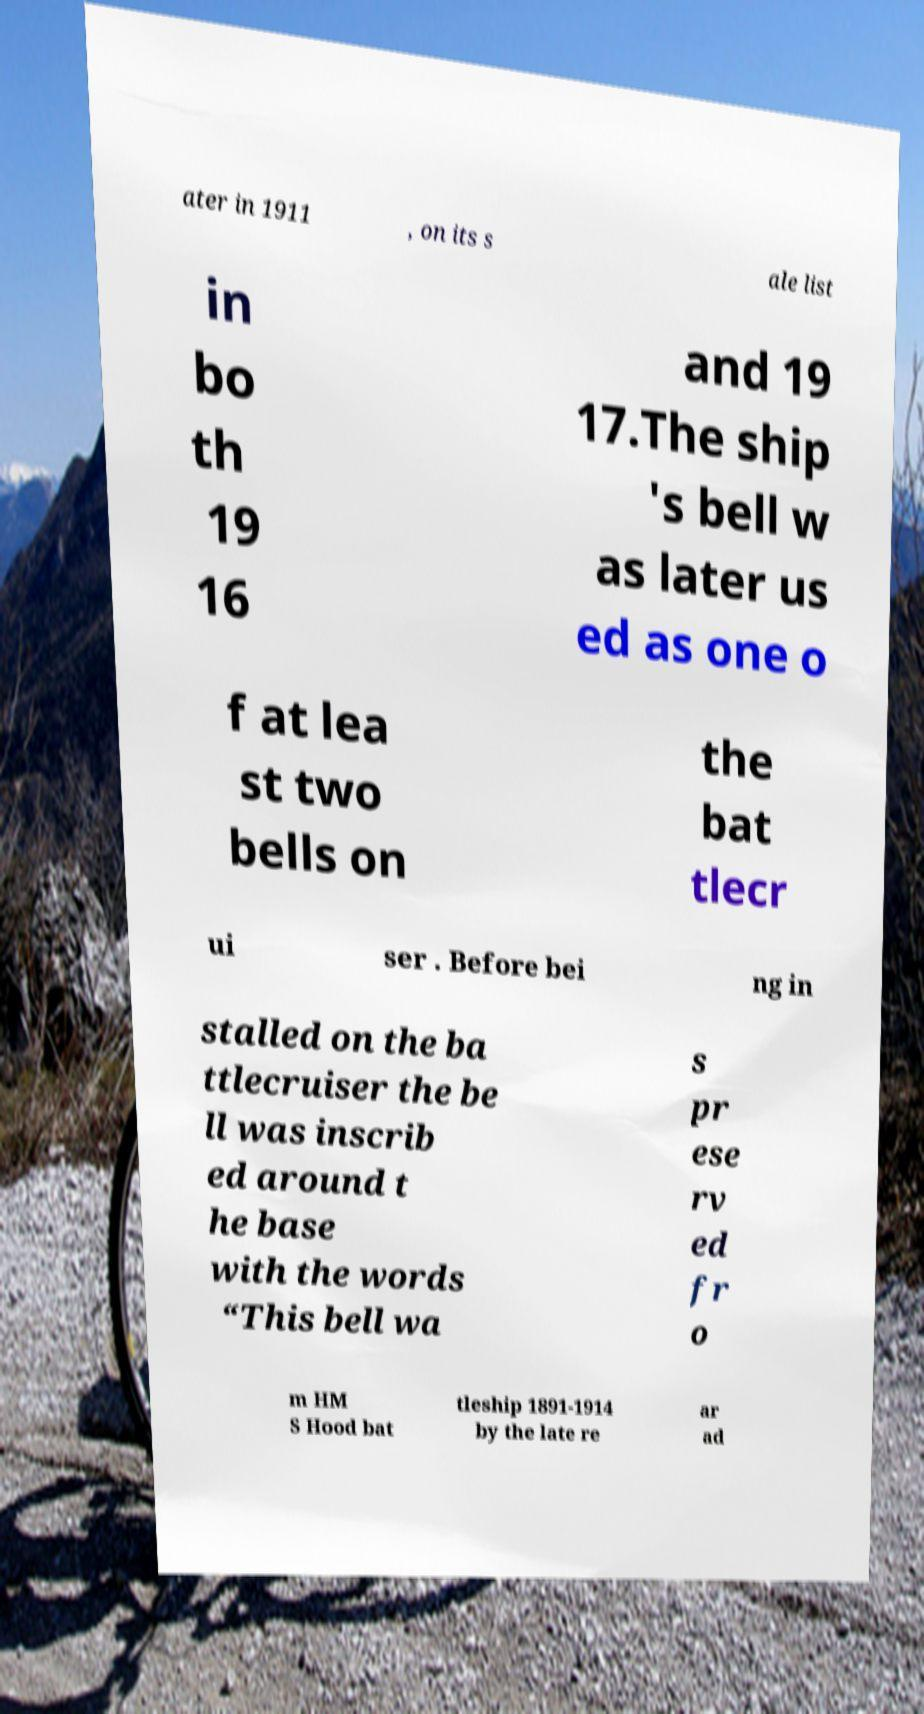Please read and relay the text visible in this image. What does it say? ater in 1911 , on its s ale list in bo th 19 16 and 19 17.The ship 's bell w as later us ed as one o f at lea st two bells on the bat tlecr ui ser . Before bei ng in stalled on the ba ttlecruiser the be ll was inscrib ed around t he base with the words “This bell wa s pr ese rv ed fr o m HM S Hood bat tleship 1891-1914 by the late re ar ad 